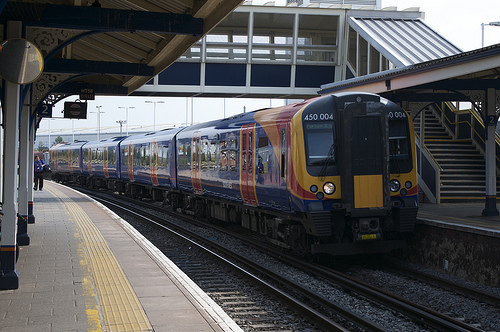Could you specify what is notable about the stairs depicted in [0.81, 0.37, 0.98, 0.57]? The stairs shown encompass a critical part of the station's infrastructure, facilitating the movement of passengers between different levels and enhancing the traffic flow within the busy station environment. 